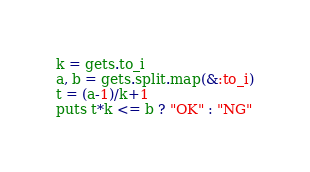Convert code to text. <code><loc_0><loc_0><loc_500><loc_500><_Ruby_>k = gets.to_i
a, b = gets.split.map(&:to_i)
t = (a-1)/k+1
puts t*k <= b ? "OK" : "NG"
</code> 